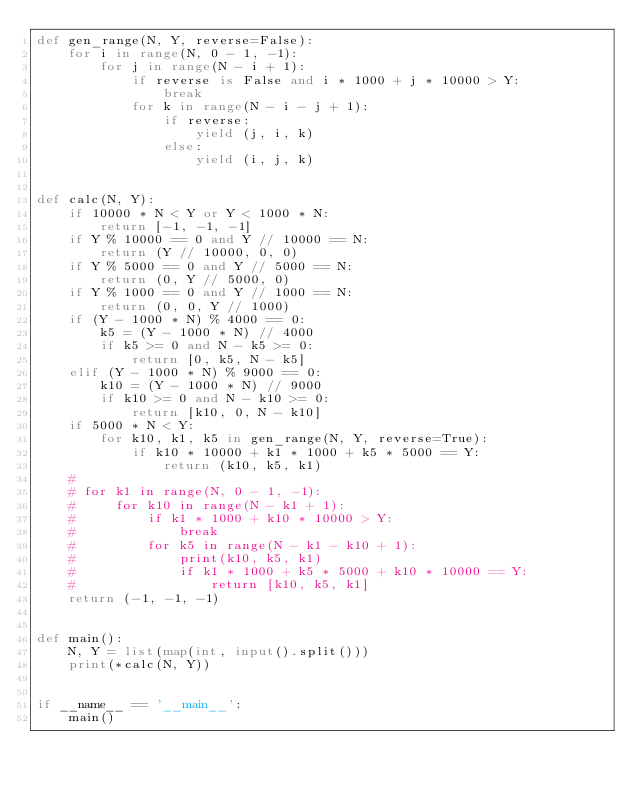<code> <loc_0><loc_0><loc_500><loc_500><_Python_>def gen_range(N, Y, reverse=False):
    for i in range(N, 0 - 1, -1):
        for j in range(N - i + 1):
            if reverse is False and i * 1000 + j * 10000 > Y:
                break
            for k in range(N - i - j + 1):
                if reverse:
                    yield (j, i, k)
                else:
                    yield (i, j, k)


def calc(N, Y):
    if 10000 * N < Y or Y < 1000 * N:
        return [-1, -1, -1]
    if Y % 10000 == 0 and Y // 10000 == N:
        return (Y // 10000, 0, 0)
    if Y % 5000 == 0 and Y // 5000 == N:
        return (0, Y // 5000, 0)
    if Y % 1000 == 0 and Y // 1000 == N:
        return (0, 0, Y // 1000)
    if (Y - 1000 * N) % 4000 == 0:
        k5 = (Y - 1000 * N) // 4000
        if k5 >= 0 and N - k5 >= 0:
            return [0, k5, N - k5]
    elif (Y - 1000 * N) % 9000 == 0:
        k10 = (Y - 1000 * N) // 9000
        if k10 >= 0 and N - k10 >= 0:
            return [k10, 0, N - k10]
    if 5000 * N < Y:
        for k10, k1, k5 in gen_range(N, Y, reverse=True):
            if k10 * 10000 + k1 * 1000 + k5 * 5000 == Y:
                return (k10, k5, k1)
    #
    # for k1 in range(N, 0 - 1, -1):
    #     for k10 in range(N - k1 + 1):
    #         if k1 * 1000 + k10 * 10000 > Y:
    #             break
    #         for k5 in range(N - k1 - k10 + 1):
    #             print(k10, k5, k1)
    #             if k1 * 1000 + k5 * 5000 + k10 * 10000 == Y:
    #                 return [k10, k5, k1]
    return (-1, -1, -1)


def main():
    N, Y = list(map(int, input().split()))
    print(*calc(N, Y))


if __name__ == '__main__':
    main()
</code> 